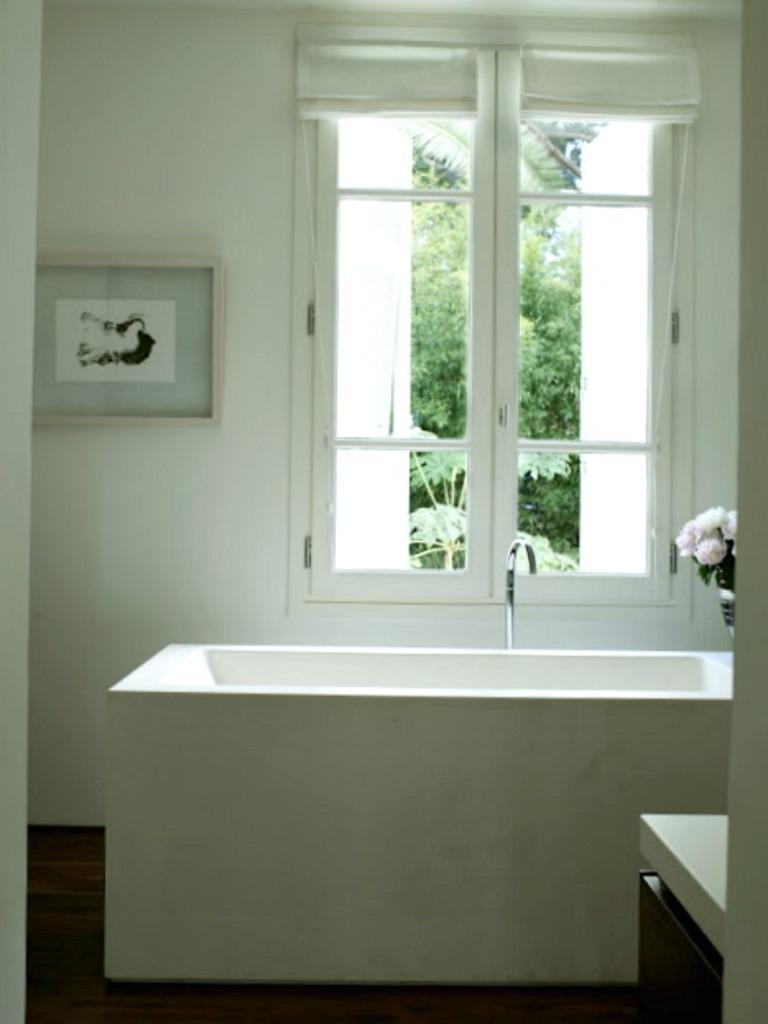What is the main object in the image? There is a bathtub in the image. What is placed on the bathtub? There is a flower vase on the bathtub. What can be seen in the background of the image? There is a frame and a window in the background of the image. What is the window's location in the room? The window is on a wall in the background of the image. What can be seen outside the window? Trees are visible through the window. How many crackers are being used as a decoration on the bathtub? There are no crackers present in the image; the bathtub has a flower vase on it. Are there any rabbits visible in the image? There are no rabbits present in the image. 